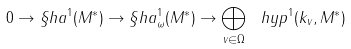<formula> <loc_0><loc_0><loc_500><loc_500>0 \to \S h a ^ { 1 } ( M ^ { * } ) \to \S h a ^ { 1 } _ { \omega } ( M ^ { * } ) \to \bigoplus _ { v \in \Omega } \ h y p ^ { 1 } ( k _ { v } , M ^ { * } )</formula> 